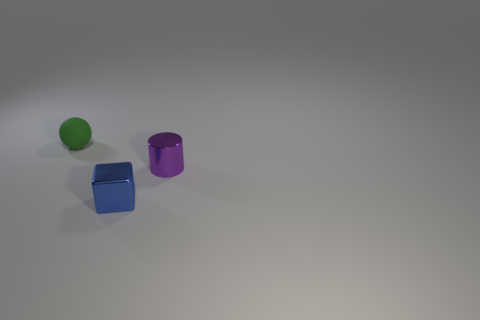Add 1 blue shiny things. How many objects exist? 4 Subtract all spheres. How many objects are left? 2 Subtract all balls. Subtract all blue metal objects. How many objects are left? 1 Add 3 matte spheres. How many matte spheres are left? 4 Add 2 large purple metal balls. How many large purple metal balls exist? 2 Subtract 0 blue spheres. How many objects are left? 3 